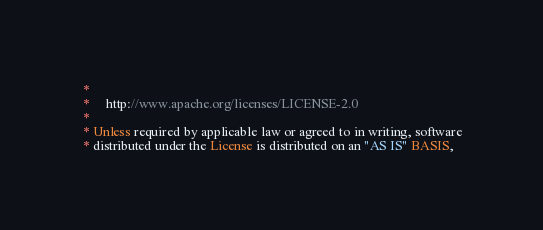Convert code to text. <code><loc_0><loc_0><loc_500><loc_500><_Scala_> *
 *     http://www.apache.org/licenses/LICENSE-2.0
 *
 * Unless required by applicable law or agreed to in writing, software
 * distributed under the License is distributed on an "AS IS" BASIS,</code> 